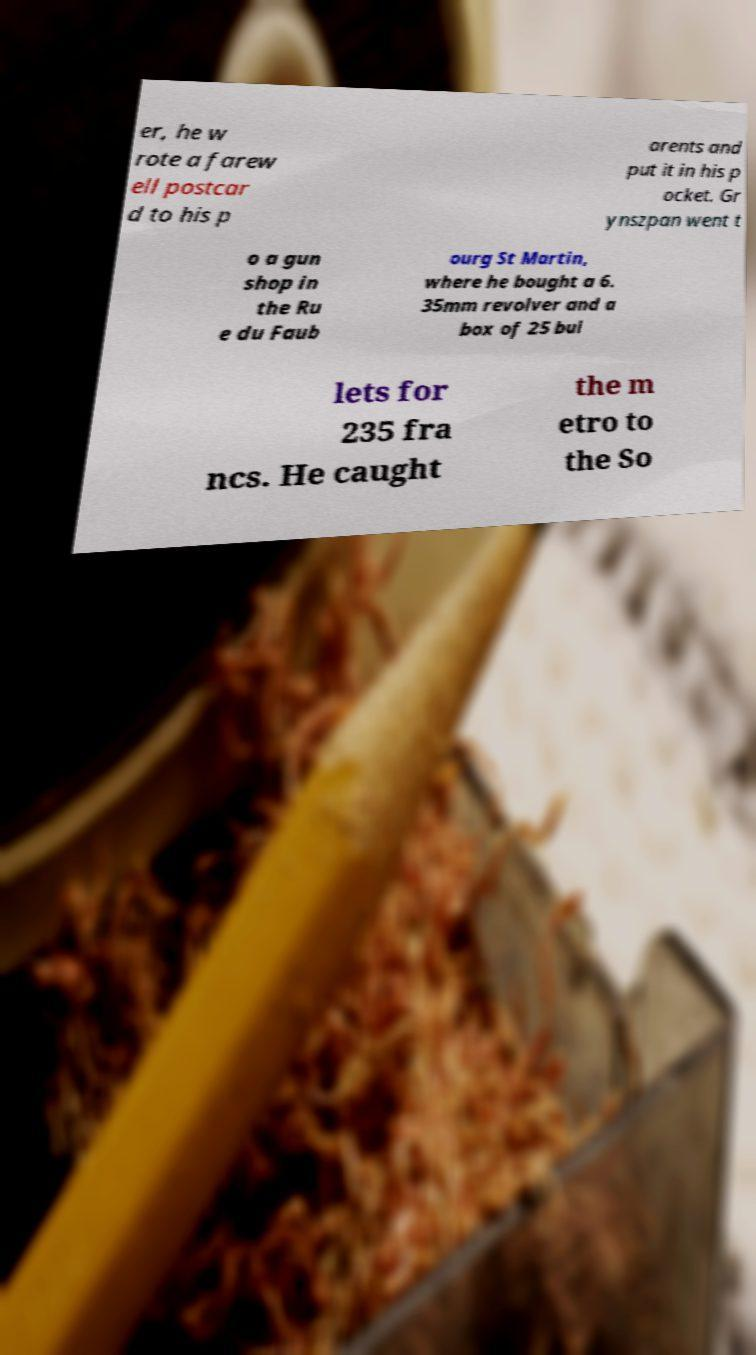There's text embedded in this image that I need extracted. Can you transcribe it verbatim? er, he w rote a farew ell postcar d to his p arents and put it in his p ocket. Gr ynszpan went t o a gun shop in the Ru e du Faub ourg St Martin, where he bought a 6. 35mm revolver and a box of 25 bul lets for 235 fra ncs. He caught the m etro to the So 